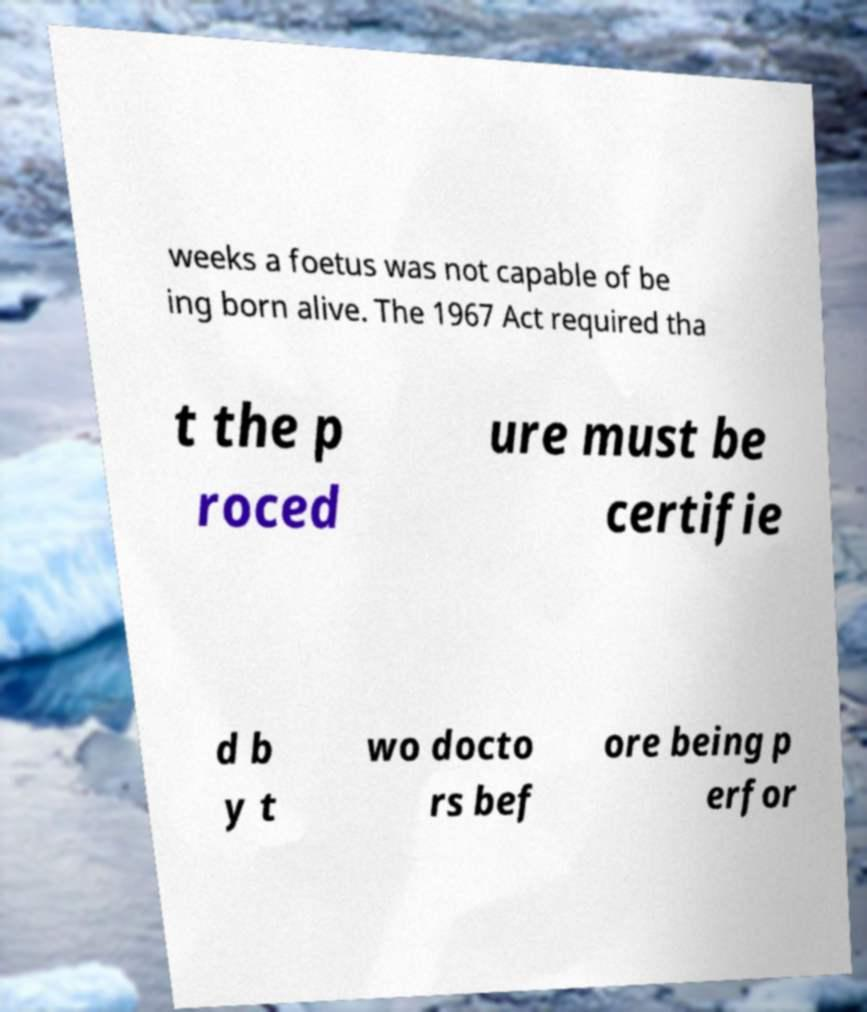What messages or text are displayed in this image? I need them in a readable, typed format. weeks a foetus was not capable of be ing born alive. The 1967 Act required tha t the p roced ure must be certifie d b y t wo docto rs bef ore being p erfor 